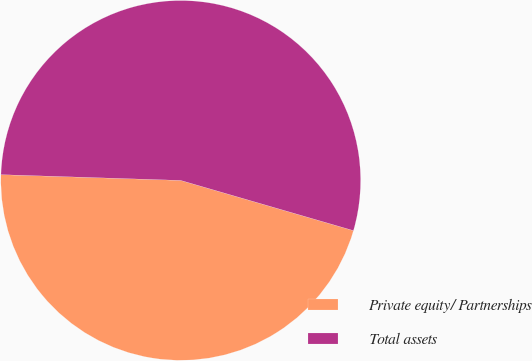Convert chart to OTSL. <chart><loc_0><loc_0><loc_500><loc_500><pie_chart><fcel>Private equity/ Partnerships<fcel>Total assets<nl><fcel>46.01%<fcel>53.99%<nl></chart> 